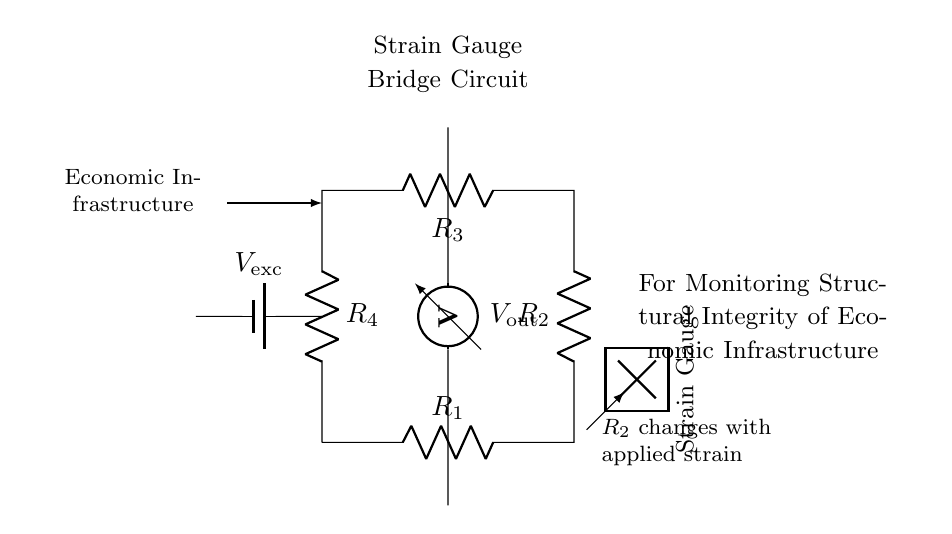What type of circuit is shown? The circuit illustrated is a strain gauge bridge circuit, designed to measure strain by detecting voltage changes.
Answer: strain gauge bridge How many resistors are in the circuit? The circuit contains four resistors arranged in a loop, forming the bridge configuration.
Answer: four What is the role of the voltmeter in this circuit? The voltmeter measures the output voltage difference, which indicates changes caused by strain in the strain gauge.
Answer: measures output voltage Which resistor is variable? Resistor R2 varies with the applied strain, as it is influenced by the deformation of the strain gauge.
Answer: R2 How does the applied strain affect the output voltage? The applied strain alters R2, creating an imbalance in the bridge circuit, which results in a change in the output voltage Vout.
Answer: output voltage changes What is the purpose of the battery in this circuit? The battery provides the excitation voltage necessary for the functioning of the bridge circuit and to create a potential difference.
Answer: provide excitation voltage What does the strain gauge indicate about the structure? The strain gauge indicates the level of strain or stress experienced by the infrastructure, enabling monitoring of its structural integrity.
Answer: structural integrity 